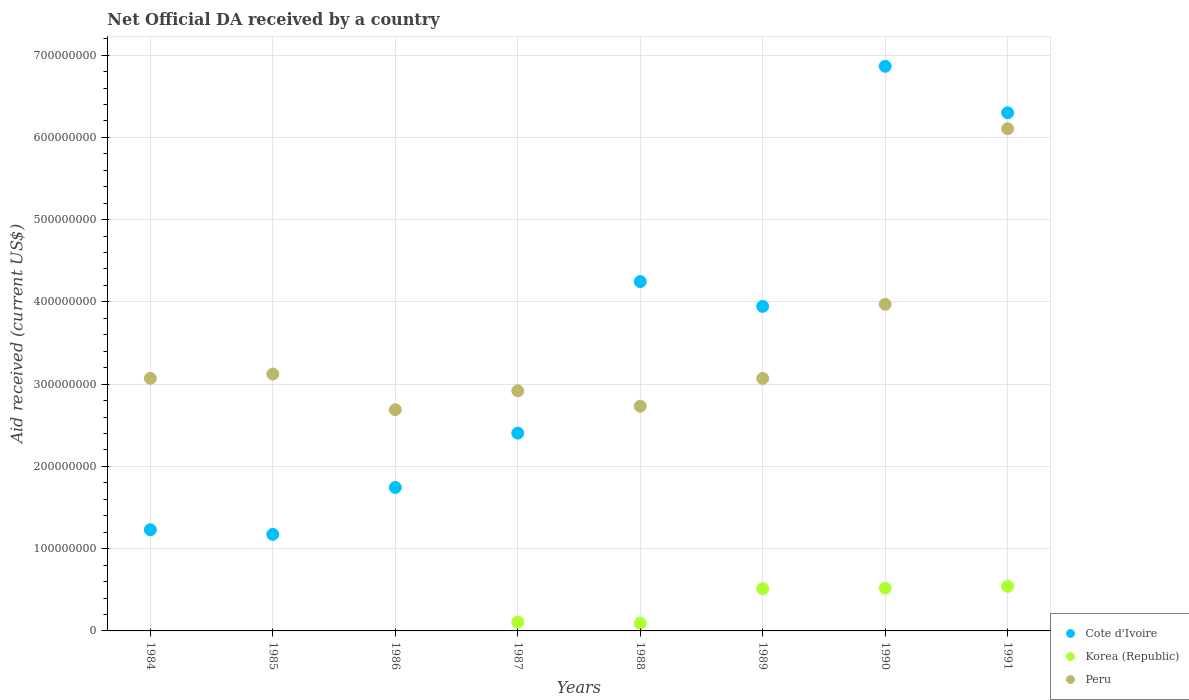What is the net official development assistance aid received in Korea (Republic) in 1987?
Your response must be concise. 1.08e+07. Across all years, what is the maximum net official development assistance aid received in Korea (Republic)?
Your response must be concise. 5.41e+07. Across all years, what is the minimum net official development assistance aid received in Cote d'Ivoire?
Ensure brevity in your answer.  1.17e+08. What is the total net official development assistance aid received in Cote d'Ivoire in the graph?
Make the answer very short. 2.79e+09. What is the difference between the net official development assistance aid received in Cote d'Ivoire in 1984 and that in 1991?
Ensure brevity in your answer.  -5.07e+08. What is the difference between the net official development assistance aid received in Peru in 1984 and the net official development assistance aid received in Korea (Republic) in 1989?
Keep it short and to the point. 2.56e+08. What is the average net official development assistance aid received in Korea (Republic) per year?
Provide a succinct answer. 2.22e+07. In the year 1987, what is the difference between the net official development assistance aid received in Cote d'Ivoire and net official development assistance aid received in Korea (Republic)?
Ensure brevity in your answer.  2.30e+08. What is the ratio of the net official development assistance aid received in Cote d'Ivoire in 1984 to that in 1988?
Your response must be concise. 0.29. What is the difference between the highest and the second highest net official development assistance aid received in Cote d'Ivoire?
Your answer should be compact. 5.65e+07. What is the difference between the highest and the lowest net official development assistance aid received in Peru?
Ensure brevity in your answer.  3.42e+08. Is the sum of the net official development assistance aid received in Peru in 1984 and 1991 greater than the maximum net official development assistance aid received in Cote d'Ivoire across all years?
Provide a short and direct response. Yes. Does the net official development assistance aid received in Korea (Republic) monotonically increase over the years?
Ensure brevity in your answer.  No. Is the net official development assistance aid received in Korea (Republic) strictly less than the net official development assistance aid received in Cote d'Ivoire over the years?
Ensure brevity in your answer.  Yes. What is the difference between two consecutive major ticks on the Y-axis?
Offer a very short reply. 1.00e+08. Are the values on the major ticks of Y-axis written in scientific E-notation?
Offer a very short reply. No. Does the graph contain any zero values?
Your response must be concise. Yes. Does the graph contain grids?
Give a very brief answer. Yes. What is the title of the graph?
Offer a terse response. Net Official DA received by a country. What is the label or title of the Y-axis?
Offer a terse response. Aid received (current US$). What is the Aid received (current US$) of Cote d'Ivoire in 1984?
Make the answer very short. 1.23e+08. What is the Aid received (current US$) of Korea (Republic) in 1984?
Your answer should be very brief. 0. What is the Aid received (current US$) of Peru in 1984?
Keep it short and to the point. 3.07e+08. What is the Aid received (current US$) in Cote d'Ivoire in 1985?
Offer a terse response. 1.17e+08. What is the Aid received (current US$) in Peru in 1985?
Your response must be concise. 3.12e+08. What is the Aid received (current US$) in Cote d'Ivoire in 1986?
Your answer should be very brief. 1.74e+08. What is the Aid received (current US$) of Peru in 1986?
Give a very brief answer. 2.69e+08. What is the Aid received (current US$) of Cote d'Ivoire in 1987?
Make the answer very short. 2.40e+08. What is the Aid received (current US$) in Korea (Republic) in 1987?
Keep it short and to the point. 1.08e+07. What is the Aid received (current US$) in Peru in 1987?
Make the answer very short. 2.92e+08. What is the Aid received (current US$) in Cote d'Ivoire in 1988?
Your answer should be very brief. 4.25e+08. What is the Aid received (current US$) of Korea (Republic) in 1988?
Keep it short and to the point. 9.36e+06. What is the Aid received (current US$) of Peru in 1988?
Offer a very short reply. 2.73e+08. What is the Aid received (current US$) in Cote d'Ivoire in 1989?
Offer a terse response. 3.95e+08. What is the Aid received (current US$) in Korea (Republic) in 1989?
Ensure brevity in your answer.  5.14e+07. What is the Aid received (current US$) of Peru in 1989?
Your response must be concise. 3.07e+08. What is the Aid received (current US$) in Cote d'Ivoire in 1990?
Provide a succinct answer. 6.86e+08. What is the Aid received (current US$) in Korea (Republic) in 1990?
Make the answer very short. 5.20e+07. What is the Aid received (current US$) in Peru in 1990?
Your answer should be compact. 3.97e+08. What is the Aid received (current US$) of Cote d'Ivoire in 1991?
Your response must be concise. 6.30e+08. What is the Aid received (current US$) of Korea (Republic) in 1991?
Provide a succinct answer. 5.41e+07. What is the Aid received (current US$) in Peru in 1991?
Ensure brevity in your answer.  6.11e+08. Across all years, what is the maximum Aid received (current US$) of Cote d'Ivoire?
Provide a short and direct response. 6.86e+08. Across all years, what is the maximum Aid received (current US$) of Korea (Republic)?
Provide a succinct answer. 5.41e+07. Across all years, what is the maximum Aid received (current US$) of Peru?
Give a very brief answer. 6.11e+08. Across all years, what is the minimum Aid received (current US$) in Cote d'Ivoire?
Provide a short and direct response. 1.17e+08. Across all years, what is the minimum Aid received (current US$) in Peru?
Ensure brevity in your answer.  2.69e+08. What is the total Aid received (current US$) in Cote d'Ivoire in the graph?
Your response must be concise. 2.79e+09. What is the total Aid received (current US$) in Korea (Republic) in the graph?
Your answer should be very brief. 1.78e+08. What is the total Aid received (current US$) of Peru in the graph?
Your answer should be very brief. 2.77e+09. What is the difference between the Aid received (current US$) in Cote d'Ivoire in 1984 and that in 1985?
Your response must be concise. 5.63e+06. What is the difference between the Aid received (current US$) of Peru in 1984 and that in 1985?
Provide a succinct answer. -5.17e+06. What is the difference between the Aid received (current US$) in Cote d'Ivoire in 1984 and that in 1986?
Your answer should be compact. -5.14e+07. What is the difference between the Aid received (current US$) in Peru in 1984 and that in 1986?
Offer a terse response. 3.82e+07. What is the difference between the Aid received (current US$) in Cote d'Ivoire in 1984 and that in 1987?
Keep it short and to the point. -1.17e+08. What is the difference between the Aid received (current US$) of Peru in 1984 and that in 1987?
Keep it short and to the point. 1.52e+07. What is the difference between the Aid received (current US$) in Cote d'Ivoire in 1984 and that in 1988?
Provide a succinct answer. -3.02e+08. What is the difference between the Aid received (current US$) in Peru in 1984 and that in 1988?
Offer a terse response. 3.39e+07. What is the difference between the Aid received (current US$) in Cote d'Ivoire in 1984 and that in 1989?
Give a very brief answer. -2.72e+08. What is the difference between the Aid received (current US$) in Cote d'Ivoire in 1984 and that in 1990?
Your answer should be very brief. -5.63e+08. What is the difference between the Aid received (current US$) of Peru in 1984 and that in 1990?
Keep it short and to the point. -9.00e+07. What is the difference between the Aid received (current US$) of Cote d'Ivoire in 1984 and that in 1991?
Offer a terse response. -5.07e+08. What is the difference between the Aid received (current US$) in Peru in 1984 and that in 1991?
Give a very brief answer. -3.03e+08. What is the difference between the Aid received (current US$) of Cote d'Ivoire in 1985 and that in 1986?
Ensure brevity in your answer.  -5.71e+07. What is the difference between the Aid received (current US$) of Peru in 1985 and that in 1986?
Your answer should be very brief. 4.34e+07. What is the difference between the Aid received (current US$) in Cote d'Ivoire in 1985 and that in 1987?
Provide a succinct answer. -1.23e+08. What is the difference between the Aid received (current US$) of Peru in 1985 and that in 1987?
Your response must be concise. 2.04e+07. What is the difference between the Aid received (current US$) of Cote d'Ivoire in 1985 and that in 1988?
Provide a short and direct response. -3.07e+08. What is the difference between the Aid received (current US$) in Peru in 1985 and that in 1988?
Offer a terse response. 3.91e+07. What is the difference between the Aid received (current US$) of Cote d'Ivoire in 1985 and that in 1989?
Your answer should be very brief. -2.77e+08. What is the difference between the Aid received (current US$) in Peru in 1985 and that in 1989?
Make the answer very short. 5.29e+06. What is the difference between the Aid received (current US$) of Cote d'Ivoire in 1985 and that in 1990?
Offer a very short reply. -5.69e+08. What is the difference between the Aid received (current US$) of Peru in 1985 and that in 1990?
Make the answer very short. -8.48e+07. What is the difference between the Aid received (current US$) of Cote d'Ivoire in 1985 and that in 1991?
Offer a terse response. -5.13e+08. What is the difference between the Aid received (current US$) of Peru in 1985 and that in 1991?
Offer a terse response. -2.98e+08. What is the difference between the Aid received (current US$) of Cote d'Ivoire in 1986 and that in 1987?
Provide a succinct answer. -6.61e+07. What is the difference between the Aid received (current US$) of Peru in 1986 and that in 1987?
Your response must be concise. -2.30e+07. What is the difference between the Aid received (current US$) in Cote d'Ivoire in 1986 and that in 1988?
Your response must be concise. -2.50e+08. What is the difference between the Aid received (current US$) in Peru in 1986 and that in 1988?
Your response must be concise. -4.25e+06. What is the difference between the Aid received (current US$) of Cote d'Ivoire in 1986 and that in 1989?
Your answer should be compact. -2.20e+08. What is the difference between the Aid received (current US$) of Peru in 1986 and that in 1989?
Keep it short and to the point. -3.81e+07. What is the difference between the Aid received (current US$) of Cote d'Ivoire in 1986 and that in 1990?
Your answer should be compact. -5.12e+08. What is the difference between the Aid received (current US$) of Peru in 1986 and that in 1990?
Your answer should be compact. -1.28e+08. What is the difference between the Aid received (current US$) of Cote d'Ivoire in 1986 and that in 1991?
Provide a short and direct response. -4.55e+08. What is the difference between the Aid received (current US$) of Peru in 1986 and that in 1991?
Provide a short and direct response. -3.42e+08. What is the difference between the Aid received (current US$) in Cote d'Ivoire in 1987 and that in 1988?
Keep it short and to the point. -1.84e+08. What is the difference between the Aid received (current US$) in Korea (Republic) in 1987 and that in 1988?
Offer a very short reply. 1.39e+06. What is the difference between the Aid received (current US$) in Peru in 1987 and that in 1988?
Your answer should be compact. 1.88e+07. What is the difference between the Aid received (current US$) in Cote d'Ivoire in 1987 and that in 1989?
Offer a terse response. -1.54e+08. What is the difference between the Aid received (current US$) of Korea (Republic) in 1987 and that in 1989?
Your answer should be very brief. -4.06e+07. What is the difference between the Aid received (current US$) of Peru in 1987 and that in 1989?
Make the answer very short. -1.51e+07. What is the difference between the Aid received (current US$) in Cote d'Ivoire in 1987 and that in 1990?
Ensure brevity in your answer.  -4.46e+08. What is the difference between the Aid received (current US$) of Korea (Republic) in 1987 and that in 1990?
Ensure brevity in your answer.  -4.12e+07. What is the difference between the Aid received (current US$) in Peru in 1987 and that in 1990?
Provide a short and direct response. -1.05e+08. What is the difference between the Aid received (current US$) in Cote d'Ivoire in 1987 and that in 1991?
Your response must be concise. -3.89e+08. What is the difference between the Aid received (current US$) of Korea (Republic) in 1987 and that in 1991?
Provide a succinct answer. -4.34e+07. What is the difference between the Aid received (current US$) of Peru in 1987 and that in 1991?
Your response must be concise. -3.19e+08. What is the difference between the Aid received (current US$) in Cote d'Ivoire in 1988 and that in 1989?
Make the answer very short. 3.02e+07. What is the difference between the Aid received (current US$) in Korea (Republic) in 1988 and that in 1989?
Provide a short and direct response. -4.20e+07. What is the difference between the Aid received (current US$) of Peru in 1988 and that in 1989?
Your answer should be very brief. -3.38e+07. What is the difference between the Aid received (current US$) of Cote d'Ivoire in 1988 and that in 1990?
Make the answer very short. -2.62e+08. What is the difference between the Aid received (current US$) of Korea (Republic) in 1988 and that in 1990?
Ensure brevity in your answer.  -4.26e+07. What is the difference between the Aid received (current US$) of Peru in 1988 and that in 1990?
Ensure brevity in your answer.  -1.24e+08. What is the difference between the Aid received (current US$) in Cote d'Ivoire in 1988 and that in 1991?
Your answer should be compact. -2.05e+08. What is the difference between the Aid received (current US$) of Korea (Republic) in 1988 and that in 1991?
Your response must be concise. -4.48e+07. What is the difference between the Aid received (current US$) in Peru in 1988 and that in 1991?
Offer a very short reply. -3.37e+08. What is the difference between the Aid received (current US$) of Cote d'Ivoire in 1989 and that in 1990?
Offer a terse response. -2.92e+08. What is the difference between the Aid received (current US$) in Korea (Republic) in 1989 and that in 1990?
Provide a short and direct response. -6.10e+05. What is the difference between the Aid received (current US$) of Peru in 1989 and that in 1990?
Your answer should be very brief. -9.01e+07. What is the difference between the Aid received (current US$) of Cote d'Ivoire in 1989 and that in 1991?
Your answer should be compact. -2.35e+08. What is the difference between the Aid received (current US$) of Korea (Republic) in 1989 and that in 1991?
Your answer should be compact. -2.74e+06. What is the difference between the Aid received (current US$) in Peru in 1989 and that in 1991?
Ensure brevity in your answer.  -3.04e+08. What is the difference between the Aid received (current US$) of Cote d'Ivoire in 1990 and that in 1991?
Make the answer very short. 5.65e+07. What is the difference between the Aid received (current US$) of Korea (Republic) in 1990 and that in 1991?
Ensure brevity in your answer.  -2.13e+06. What is the difference between the Aid received (current US$) in Peru in 1990 and that in 1991?
Provide a succinct answer. -2.13e+08. What is the difference between the Aid received (current US$) in Cote d'Ivoire in 1984 and the Aid received (current US$) in Peru in 1985?
Give a very brief answer. -1.89e+08. What is the difference between the Aid received (current US$) of Cote d'Ivoire in 1984 and the Aid received (current US$) of Peru in 1986?
Provide a short and direct response. -1.46e+08. What is the difference between the Aid received (current US$) in Cote d'Ivoire in 1984 and the Aid received (current US$) in Korea (Republic) in 1987?
Make the answer very short. 1.12e+08. What is the difference between the Aid received (current US$) of Cote d'Ivoire in 1984 and the Aid received (current US$) of Peru in 1987?
Your answer should be compact. -1.69e+08. What is the difference between the Aid received (current US$) of Cote d'Ivoire in 1984 and the Aid received (current US$) of Korea (Republic) in 1988?
Ensure brevity in your answer.  1.14e+08. What is the difference between the Aid received (current US$) of Cote d'Ivoire in 1984 and the Aid received (current US$) of Peru in 1988?
Offer a terse response. -1.50e+08. What is the difference between the Aid received (current US$) of Cote d'Ivoire in 1984 and the Aid received (current US$) of Korea (Republic) in 1989?
Offer a very short reply. 7.16e+07. What is the difference between the Aid received (current US$) in Cote d'Ivoire in 1984 and the Aid received (current US$) in Peru in 1989?
Your answer should be compact. -1.84e+08. What is the difference between the Aid received (current US$) in Cote d'Ivoire in 1984 and the Aid received (current US$) in Korea (Republic) in 1990?
Your response must be concise. 7.10e+07. What is the difference between the Aid received (current US$) in Cote d'Ivoire in 1984 and the Aid received (current US$) in Peru in 1990?
Make the answer very short. -2.74e+08. What is the difference between the Aid received (current US$) of Cote d'Ivoire in 1984 and the Aid received (current US$) of Korea (Republic) in 1991?
Keep it short and to the point. 6.89e+07. What is the difference between the Aid received (current US$) in Cote d'Ivoire in 1984 and the Aid received (current US$) in Peru in 1991?
Offer a terse response. -4.88e+08. What is the difference between the Aid received (current US$) of Cote d'Ivoire in 1985 and the Aid received (current US$) of Peru in 1986?
Your answer should be very brief. -1.52e+08. What is the difference between the Aid received (current US$) of Cote d'Ivoire in 1985 and the Aid received (current US$) of Korea (Republic) in 1987?
Keep it short and to the point. 1.07e+08. What is the difference between the Aid received (current US$) in Cote d'Ivoire in 1985 and the Aid received (current US$) in Peru in 1987?
Provide a succinct answer. -1.75e+08. What is the difference between the Aid received (current US$) of Cote d'Ivoire in 1985 and the Aid received (current US$) of Korea (Republic) in 1988?
Provide a short and direct response. 1.08e+08. What is the difference between the Aid received (current US$) of Cote d'Ivoire in 1985 and the Aid received (current US$) of Peru in 1988?
Offer a terse response. -1.56e+08. What is the difference between the Aid received (current US$) in Cote d'Ivoire in 1985 and the Aid received (current US$) in Korea (Republic) in 1989?
Your response must be concise. 6.60e+07. What is the difference between the Aid received (current US$) in Cote d'Ivoire in 1985 and the Aid received (current US$) in Peru in 1989?
Give a very brief answer. -1.90e+08. What is the difference between the Aid received (current US$) in Cote d'Ivoire in 1985 and the Aid received (current US$) in Korea (Republic) in 1990?
Provide a succinct answer. 6.54e+07. What is the difference between the Aid received (current US$) of Cote d'Ivoire in 1985 and the Aid received (current US$) of Peru in 1990?
Your response must be concise. -2.80e+08. What is the difference between the Aid received (current US$) in Cote d'Ivoire in 1985 and the Aid received (current US$) in Korea (Republic) in 1991?
Keep it short and to the point. 6.32e+07. What is the difference between the Aid received (current US$) in Cote d'Ivoire in 1985 and the Aid received (current US$) in Peru in 1991?
Your answer should be very brief. -4.93e+08. What is the difference between the Aid received (current US$) in Cote d'Ivoire in 1986 and the Aid received (current US$) in Korea (Republic) in 1987?
Provide a short and direct response. 1.64e+08. What is the difference between the Aid received (current US$) in Cote d'Ivoire in 1986 and the Aid received (current US$) in Peru in 1987?
Your answer should be compact. -1.18e+08. What is the difference between the Aid received (current US$) of Cote d'Ivoire in 1986 and the Aid received (current US$) of Korea (Republic) in 1988?
Offer a terse response. 1.65e+08. What is the difference between the Aid received (current US$) in Cote d'Ivoire in 1986 and the Aid received (current US$) in Peru in 1988?
Keep it short and to the point. -9.88e+07. What is the difference between the Aid received (current US$) in Cote d'Ivoire in 1986 and the Aid received (current US$) in Korea (Republic) in 1989?
Your answer should be very brief. 1.23e+08. What is the difference between the Aid received (current US$) of Cote d'Ivoire in 1986 and the Aid received (current US$) of Peru in 1989?
Your answer should be very brief. -1.33e+08. What is the difference between the Aid received (current US$) of Cote d'Ivoire in 1986 and the Aid received (current US$) of Korea (Republic) in 1990?
Make the answer very short. 1.22e+08. What is the difference between the Aid received (current US$) of Cote d'Ivoire in 1986 and the Aid received (current US$) of Peru in 1990?
Your answer should be compact. -2.23e+08. What is the difference between the Aid received (current US$) in Cote d'Ivoire in 1986 and the Aid received (current US$) in Korea (Republic) in 1991?
Keep it short and to the point. 1.20e+08. What is the difference between the Aid received (current US$) in Cote d'Ivoire in 1986 and the Aid received (current US$) in Peru in 1991?
Offer a very short reply. -4.36e+08. What is the difference between the Aid received (current US$) of Cote d'Ivoire in 1987 and the Aid received (current US$) of Korea (Republic) in 1988?
Your answer should be very brief. 2.31e+08. What is the difference between the Aid received (current US$) in Cote d'Ivoire in 1987 and the Aid received (current US$) in Peru in 1988?
Provide a succinct answer. -3.27e+07. What is the difference between the Aid received (current US$) of Korea (Republic) in 1987 and the Aid received (current US$) of Peru in 1988?
Offer a very short reply. -2.62e+08. What is the difference between the Aid received (current US$) of Cote d'Ivoire in 1987 and the Aid received (current US$) of Korea (Republic) in 1989?
Make the answer very short. 1.89e+08. What is the difference between the Aid received (current US$) of Cote d'Ivoire in 1987 and the Aid received (current US$) of Peru in 1989?
Your response must be concise. -6.65e+07. What is the difference between the Aid received (current US$) in Korea (Republic) in 1987 and the Aid received (current US$) in Peru in 1989?
Your answer should be very brief. -2.96e+08. What is the difference between the Aid received (current US$) of Cote d'Ivoire in 1987 and the Aid received (current US$) of Korea (Republic) in 1990?
Your answer should be very brief. 1.88e+08. What is the difference between the Aid received (current US$) in Cote d'Ivoire in 1987 and the Aid received (current US$) in Peru in 1990?
Provide a succinct answer. -1.57e+08. What is the difference between the Aid received (current US$) in Korea (Republic) in 1987 and the Aid received (current US$) in Peru in 1990?
Make the answer very short. -3.86e+08. What is the difference between the Aid received (current US$) in Cote d'Ivoire in 1987 and the Aid received (current US$) in Korea (Republic) in 1991?
Make the answer very short. 1.86e+08. What is the difference between the Aid received (current US$) of Cote d'Ivoire in 1987 and the Aid received (current US$) of Peru in 1991?
Ensure brevity in your answer.  -3.70e+08. What is the difference between the Aid received (current US$) of Korea (Republic) in 1987 and the Aid received (current US$) of Peru in 1991?
Offer a very short reply. -6.00e+08. What is the difference between the Aid received (current US$) of Cote d'Ivoire in 1988 and the Aid received (current US$) of Korea (Republic) in 1989?
Your response must be concise. 3.73e+08. What is the difference between the Aid received (current US$) of Cote d'Ivoire in 1988 and the Aid received (current US$) of Peru in 1989?
Keep it short and to the point. 1.18e+08. What is the difference between the Aid received (current US$) in Korea (Republic) in 1988 and the Aid received (current US$) in Peru in 1989?
Give a very brief answer. -2.98e+08. What is the difference between the Aid received (current US$) of Cote d'Ivoire in 1988 and the Aid received (current US$) of Korea (Republic) in 1990?
Your answer should be compact. 3.73e+08. What is the difference between the Aid received (current US$) of Cote d'Ivoire in 1988 and the Aid received (current US$) of Peru in 1990?
Provide a succinct answer. 2.76e+07. What is the difference between the Aid received (current US$) in Korea (Republic) in 1988 and the Aid received (current US$) in Peru in 1990?
Offer a terse response. -3.88e+08. What is the difference between the Aid received (current US$) of Cote d'Ivoire in 1988 and the Aid received (current US$) of Korea (Republic) in 1991?
Give a very brief answer. 3.71e+08. What is the difference between the Aid received (current US$) in Cote d'Ivoire in 1988 and the Aid received (current US$) in Peru in 1991?
Keep it short and to the point. -1.86e+08. What is the difference between the Aid received (current US$) in Korea (Republic) in 1988 and the Aid received (current US$) in Peru in 1991?
Your answer should be compact. -6.01e+08. What is the difference between the Aid received (current US$) in Cote d'Ivoire in 1989 and the Aid received (current US$) in Korea (Republic) in 1990?
Your answer should be compact. 3.43e+08. What is the difference between the Aid received (current US$) in Cote d'Ivoire in 1989 and the Aid received (current US$) in Peru in 1990?
Your response must be concise. -2.52e+06. What is the difference between the Aid received (current US$) in Korea (Republic) in 1989 and the Aid received (current US$) in Peru in 1990?
Make the answer very short. -3.46e+08. What is the difference between the Aid received (current US$) of Cote d'Ivoire in 1989 and the Aid received (current US$) of Korea (Republic) in 1991?
Your answer should be very brief. 3.40e+08. What is the difference between the Aid received (current US$) of Cote d'Ivoire in 1989 and the Aid received (current US$) of Peru in 1991?
Offer a very short reply. -2.16e+08. What is the difference between the Aid received (current US$) of Korea (Republic) in 1989 and the Aid received (current US$) of Peru in 1991?
Ensure brevity in your answer.  -5.59e+08. What is the difference between the Aid received (current US$) in Cote d'Ivoire in 1990 and the Aid received (current US$) in Korea (Republic) in 1991?
Offer a very short reply. 6.32e+08. What is the difference between the Aid received (current US$) in Cote d'Ivoire in 1990 and the Aid received (current US$) in Peru in 1991?
Offer a terse response. 7.59e+07. What is the difference between the Aid received (current US$) of Korea (Republic) in 1990 and the Aid received (current US$) of Peru in 1991?
Offer a very short reply. -5.59e+08. What is the average Aid received (current US$) in Cote d'Ivoire per year?
Provide a short and direct response. 3.49e+08. What is the average Aid received (current US$) in Korea (Republic) per year?
Your response must be concise. 2.22e+07. What is the average Aid received (current US$) in Peru per year?
Give a very brief answer. 3.46e+08. In the year 1984, what is the difference between the Aid received (current US$) in Cote d'Ivoire and Aid received (current US$) in Peru?
Your response must be concise. -1.84e+08. In the year 1985, what is the difference between the Aid received (current US$) of Cote d'Ivoire and Aid received (current US$) of Peru?
Make the answer very short. -1.95e+08. In the year 1986, what is the difference between the Aid received (current US$) of Cote d'Ivoire and Aid received (current US$) of Peru?
Your answer should be compact. -9.45e+07. In the year 1987, what is the difference between the Aid received (current US$) in Cote d'Ivoire and Aid received (current US$) in Korea (Republic)?
Provide a succinct answer. 2.30e+08. In the year 1987, what is the difference between the Aid received (current US$) of Cote d'Ivoire and Aid received (current US$) of Peru?
Offer a terse response. -5.15e+07. In the year 1987, what is the difference between the Aid received (current US$) of Korea (Republic) and Aid received (current US$) of Peru?
Offer a very short reply. -2.81e+08. In the year 1988, what is the difference between the Aid received (current US$) in Cote d'Ivoire and Aid received (current US$) in Korea (Republic)?
Keep it short and to the point. 4.15e+08. In the year 1988, what is the difference between the Aid received (current US$) of Cote d'Ivoire and Aid received (current US$) of Peru?
Offer a very short reply. 1.52e+08. In the year 1988, what is the difference between the Aid received (current US$) in Korea (Republic) and Aid received (current US$) in Peru?
Offer a very short reply. -2.64e+08. In the year 1989, what is the difference between the Aid received (current US$) of Cote d'Ivoire and Aid received (current US$) of Korea (Republic)?
Your answer should be very brief. 3.43e+08. In the year 1989, what is the difference between the Aid received (current US$) in Cote d'Ivoire and Aid received (current US$) in Peru?
Keep it short and to the point. 8.76e+07. In the year 1989, what is the difference between the Aid received (current US$) in Korea (Republic) and Aid received (current US$) in Peru?
Provide a succinct answer. -2.56e+08. In the year 1990, what is the difference between the Aid received (current US$) in Cote d'Ivoire and Aid received (current US$) in Korea (Republic)?
Offer a very short reply. 6.34e+08. In the year 1990, what is the difference between the Aid received (current US$) of Cote d'Ivoire and Aid received (current US$) of Peru?
Your response must be concise. 2.89e+08. In the year 1990, what is the difference between the Aid received (current US$) in Korea (Republic) and Aid received (current US$) in Peru?
Offer a terse response. -3.45e+08. In the year 1991, what is the difference between the Aid received (current US$) of Cote d'Ivoire and Aid received (current US$) of Korea (Republic)?
Your answer should be very brief. 5.76e+08. In the year 1991, what is the difference between the Aid received (current US$) of Cote d'Ivoire and Aid received (current US$) of Peru?
Ensure brevity in your answer.  1.94e+07. In the year 1991, what is the difference between the Aid received (current US$) of Korea (Republic) and Aid received (current US$) of Peru?
Provide a succinct answer. -5.56e+08. What is the ratio of the Aid received (current US$) in Cote d'Ivoire in 1984 to that in 1985?
Ensure brevity in your answer.  1.05. What is the ratio of the Aid received (current US$) of Peru in 1984 to that in 1985?
Provide a succinct answer. 0.98. What is the ratio of the Aid received (current US$) of Cote d'Ivoire in 1984 to that in 1986?
Make the answer very short. 0.71. What is the ratio of the Aid received (current US$) of Peru in 1984 to that in 1986?
Give a very brief answer. 1.14. What is the ratio of the Aid received (current US$) of Cote d'Ivoire in 1984 to that in 1987?
Offer a very short reply. 0.51. What is the ratio of the Aid received (current US$) in Peru in 1984 to that in 1987?
Your answer should be compact. 1.05. What is the ratio of the Aid received (current US$) in Cote d'Ivoire in 1984 to that in 1988?
Provide a succinct answer. 0.29. What is the ratio of the Aid received (current US$) of Peru in 1984 to that in 1988?
Ensure brevity in your answer.  1.12. What is the ratio of the Aid received (current US$) of Cote d'Ivoire in 1984 to that in 1989?
Keep it short and to the point. 0.31. What is the ratio of the Aid received (current US$) in Peru in 1984 to that in 1989?
Offer a terse response. 1. What is the ratio of the Aid received (current US$) of Cote d'Ivoire in 1984 to that in 1990?
Offer a very short reply. 0.18. What is the ratio of the Aid received (current US$) of Peru in 1984 to that in 1990?
Offer a terse response. 0.77. What is the ratio of the Aid received (current US$) in Cote d'Ivoire in 1984 to that in 1991?
Your answer should be compact. 0.2. What is the ratio of the Aid received (current US$) of Peru in 1984 to that in 1991?
Offer a very short reply. 0.5. What is the ratio of the Aid received (current US$) in Cote d'Ivoire in 1985 to that in 1986?
Your response must be concise. 0.67. What is the ratio of the Aid received (current US$) of Peru in 1985 to that in 1986?
Make the answer very short. 1.16. What is the ratio of the Aid received (current US$) of Cote d'Ivoire in 1985 to that in 1987?
Ensure brevity in your answer.  0.49. What is the ratio of the Aid received (current US$) of Peru in 1985 to that in 1987?
Offer a very short reply. 1.07. What is the ratio of the Aid received (current US$) in Cote d'Ivoire in 1985 to that in 1988?
Your answer should be very brief. 0.28. What is the ratio of the Aid received (current US$) of Peru in 1985 to that in 1988?
Your answer should be very brief. 1.14. What is the ratio of the Aid received (current US$) of Cote d'Ivoire in 1985 to that in 1989?
Your response must be concise. 0.3. What is the ratio of the Aid received (current US$) of Peru in 1985 to that in 1989?
Offer a very short reply. 1.02. What is the ratio of the Aid received (current US$) in Cote d'Ivoire in 1985 to that in 1990?
Give a very brief answer. 0.17. What is the ratio of the Aid received (current US$) in Peru in 1985 to that in 1990?
Make the answer very short. 0.79. What is the ratio of the Aid received (current US$) in Cote d'Ivoire in 1985 to that in 1991?
Give a very brief answer. 0.19. What is the ratio of the Aid received (current US$) of Peru in 1985 to that in 1991?
Provide a short and direct response. 0.51. What is the ratio of the Aid received (current US$) in Cote d'Ivoire in 1986 to that in 1987?
Make the answer very short. 0.73. What is the ratio of the Aid received (current US$) of Peru in 1986 to that in 1987?
Provide a succinct answer. 0.92. What is the ratio of the Aid received (current US$) in Cote d'Ivoire in 1986 to that in 1988?
Make the answer very short. 0.41. What is the ratio of the Aid received (current US$) in Peru in 1986 to that in 1988?
Make the answer very short. 0.98. What is the ratio of the Aid received (current US$) in Cote d'Ivoire in 1986 to that in 1989?
Ensure brevity in your answer.  0.44. What is the ratio of the Aid received (current US$) in Peru in 1986 to that in 1989?
Offer a terse response. 0.88. What is the ratio of the Aid received (current US$) in Cote d'Ivoire in 1986 to that in 1990?
Offer a very short reply. 0.25. What is the ratio of the Aid received (current US$) in Peru in 1986 to that in 1990?
Ensure brevity in your answer.  0.68. What is the ratio of the Aid received (current US$) in Cote d'Ivoire in 1986 to that in 1991?
Your answer should be compact. 0.28. What is the ratio of the Aid received (current US$) in Peru in 1986 to that in 1991?
Provide a succinct answer. 0.44. What is the ratio of the Aid received (current US$) in Cote d'Ivoire in 1987 to that in 1988?
Give a very brief answer. 0.57. What is the ratio of the Aid received (current US$) of Korea (Republic) in 1987 to that in 1988?
Your response must be concise. 1.15. What is the ratio of the Aid received (current US$) in Peru in 1987 to that in 1988?
Make the answer very short. 1.07. What is the ratio of the Aid received (current US$) in Cote d'Ivoire in 1987 to that in 1989?
Offer a terse response. 0.61. What is the ratio of the Aid received (current US$) in Korea (Republic) in 1987 to that in 1989?
Your response must be concise. 0.21. What is the ratio of the Aid received (current US$) of Peru in 1987 to that in 1989?
Your answer should be compact. 0.95. What is the ratio of the Aid received (current US$) of Cote d'Ivoire in 1987 to that in 1990?
Keep it short and to the point. 0.35. What is the ratio of the Aid received (current US$) in Korea (Republic) in 1987 to that in 1990?
Your response must be concise. 0.21. What is the ratio of the Aid received (current US$) in Peru in 1987 to that in 1990?
Your answer should be very brief. 0.74. What is the ratio of the Aid received (current US$) in Cote d'Ivoire in 1987 to that in 1991?
Your answer should be very brief. 0.38. What is the ratio of the Aid received (current US$) in Korea (Republic) in 1987 to that in 1991?
Ensure brevity in your answer.  0.2. What is the ratio of the Aid received (current US$) in Peru in 1987 to that in 1991?
Offer a very short reply. 0.48. What is the ratio of the Aid received (current US$) in Cote d'Ivoire in 1988 to that in 1989?
Your answer should be compact. 1.08. What is the ratio of the Aid received (current US$) in Korea (Republic) in 1988 to that in 1989?
Provide a short and direct response. 0.18. What is the ratio of the Aid received (current US$) of Peru in 1988 to that in 1989?
Ensure brevity in your answer.  0.89. What is the ratio of the Aid received (current US$) of Cote d'Ivoire in 1988 to that in 1990?
Give a very brief answer. 0.62. What is the ratio of the Aid received (current US$) in Korea (Republic) in 1988 to that in 1990?
Offer a terse response. 0.18. What is the ratio of the Aid received (current US$) of Peru in 1988 to that in 1990?
Provide a short and direct response. 0.69. What is the ratio of the Aid received (current US$) of Cote d'Ivoire in 1988 to that in 1991?
Ensure brevity in your answer.  0.67. What is the ratio of the Aid received (current US$) in Korea (Republic) in 1988 to that in 1991?
Provide a succinct answer. 0.17. What is the ratio of the Aid received (current US$) of Peru in 1988 to that in 1991?
Keep it short and to the point. 0.45. What is the ratio of the Aid received (current US$) in Cote d'Ivoire in 1989 to that in 1990?
Your response must be concise. 0.57. What is the ratio of the Aid received (current US$) in Korea (Republic) in 1989 to that in 1990?
Offer a very short reply. 0.99. What is the ratio of the Aid received (current US$) in Peru in 1989 to that in 1990?
Keep it short and to the point. 0.77. What is the ratio of the Aid received (current US$) of Cote d'Ivoire in 1989 to that in 1991?
Keep it short and to the point. 0.63. What is the ratio of the Aid received (current US$) of Korea (Republic) in 1989 to that in 1991?
Ensure brevity in your answer.  0.95. What is the ratio of the Aid received (current US$) of Peru in 1989 to that in 1991?
Your answer should be very brief. 0.5. What is the ratio of the Aid received (current US$) in Cote d'Ivoire in 1990 to that in 1991?
Offer a terse response. 1.09. What is the ratio of the Aid received (current US$) in Korea (Republic) in 1990 to that in 1991?
Offer a very short reply. 0.96. What is the ratio of the Aid received (current US$) of Peru in 1990 to that in 1991?
Keep it short and to the point. 0.65. What is the difference between the highest and the second highest Aid received (current US$) of Cote d'Ivoire?
Ensure brevity in your answer.  5.65e+07. What is the difference between the highest and the second highest Aid received (current US$) of Korea (Republic)?
Your response must be concise. 2.13e+06. What is the difference between the highest and the second highest Aid received (current US$) of Peru?
Provide a succinct answer. 2.13e+08. What is the difference between the highest and the lowest Aid received (current US$) of Cote d'Ivoire?
Your answer should be compact. 5.69e+08. What is the difference between the highest and the lowest Aid received (current US$) of Korea (Republic)?
Make the answer very short. 5.41e+07. What is the difference between the highest and the lowest Aid received (current US$) of Peru?
Keep it short and to the point. 3.42e+08. 